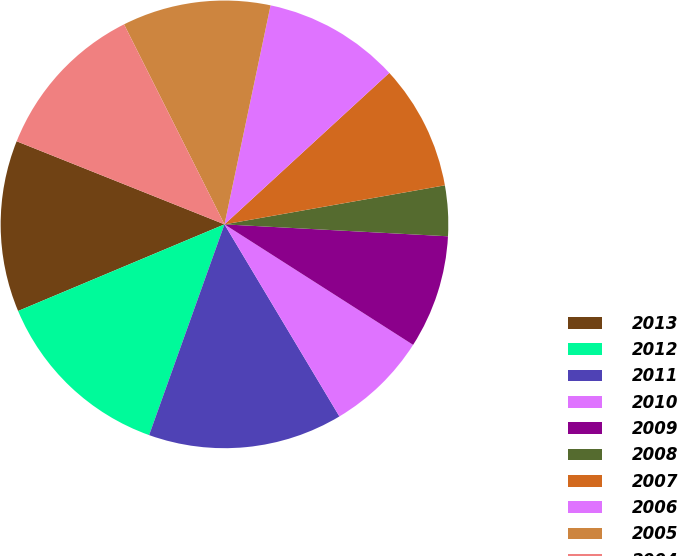<chart> <loc_0><loc_0><loc_500><loc_500><pie_chart><fcel>2013<fcel>2012<fcel>2011<fcel>2010<fcel>2009<fcel>2008<fcel>2007<fcel>2006<fcel>2005<fcel>2004<nl><fcel>12.38%<fcel>13.21%<fcel>14.05%<fcel>7.37%<fcel>8.2%<fcel>3.64%<fcel>9.04%<fcel>9.87%<fcel>10.71%<fcel>11.54%<nl></chart> 